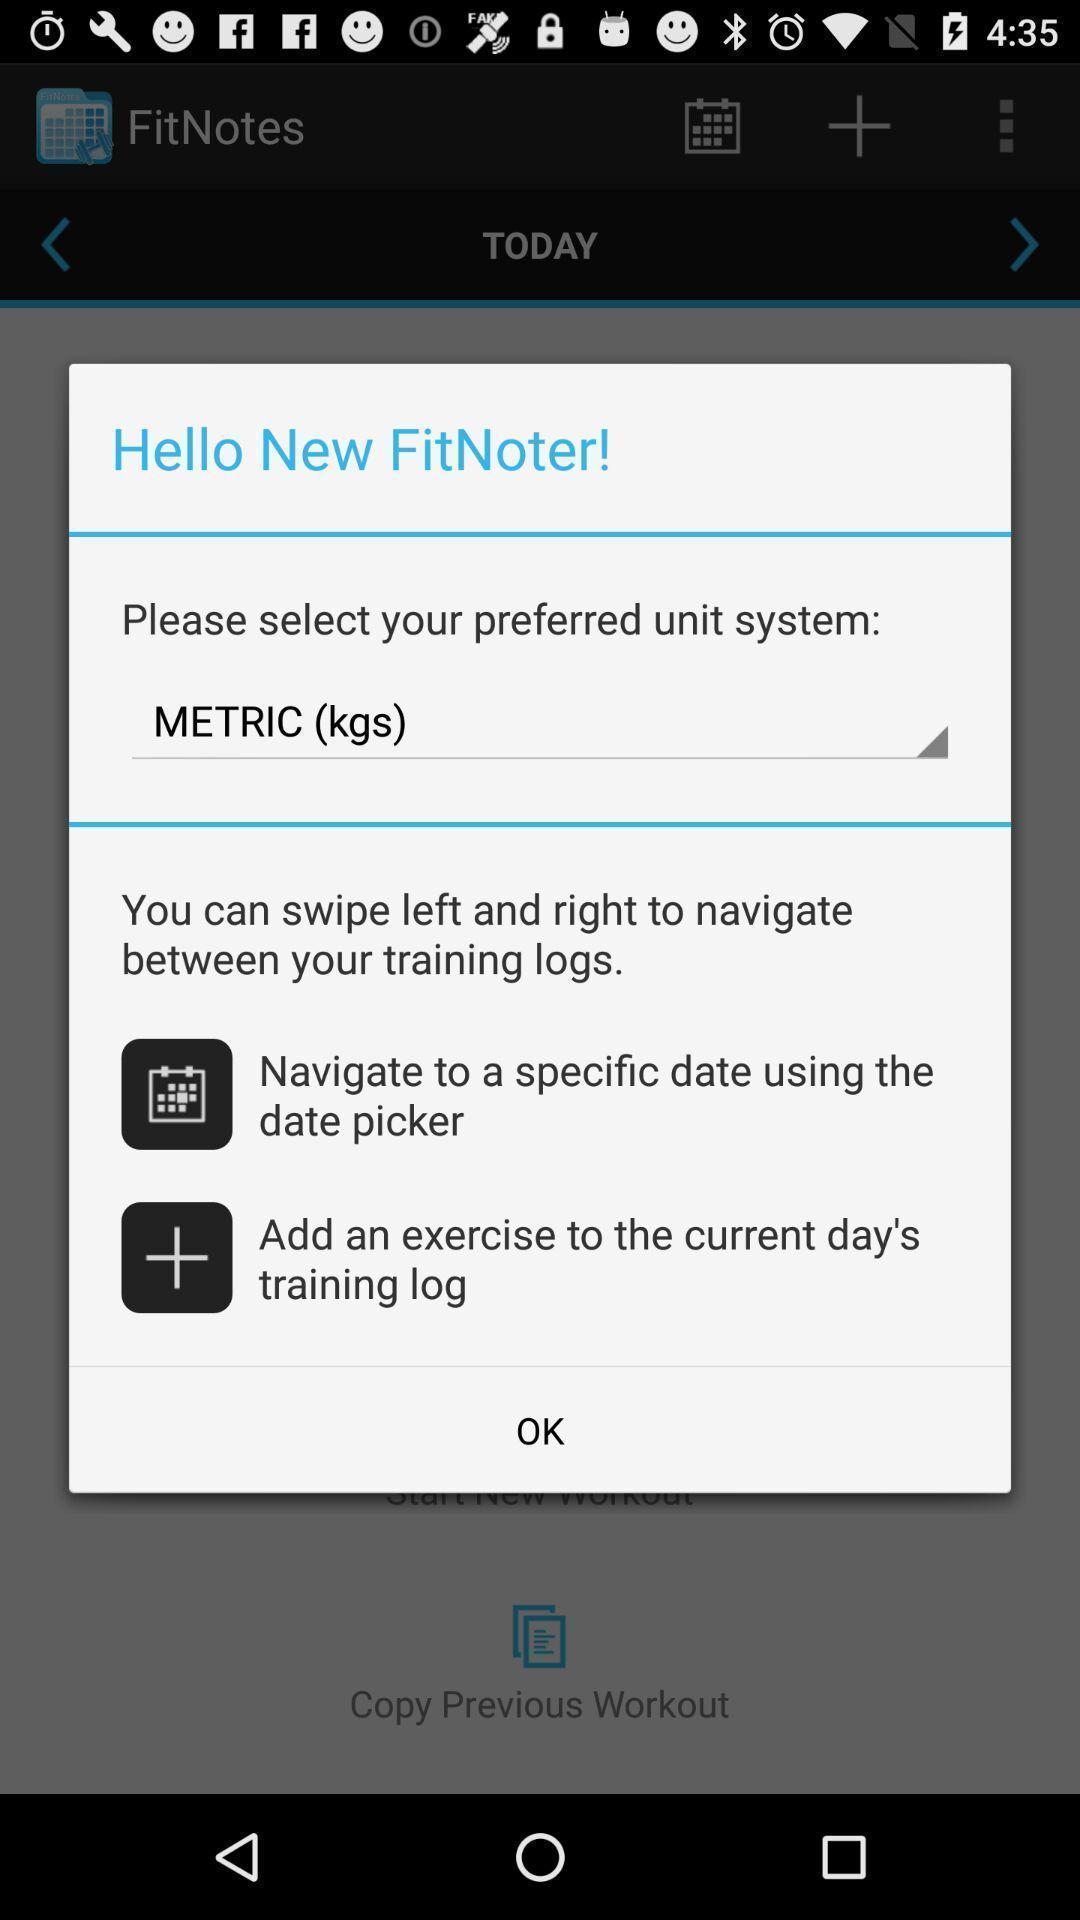Describe this image in words. Pop up window for workout tracker. 